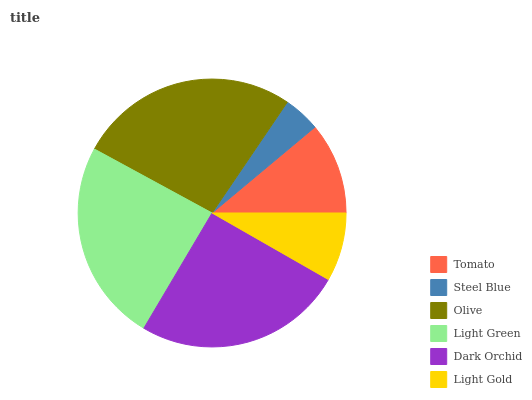Is Steel Blue the minimum?
Answer yes or no. Yes. Is Olive the maximum?
Answer yes or no. Yes. Is Olive the minimum?
Answer yes or no. No. Is Steel Blue the maximum?
Answer yes or no. No. Is Olive greater than Steel Blue?
Answer yes or no. Yes. Is Steel Blue less than Olive?
Answer yes or no. Yes. Is Steel Blue greater than Olive?
Answer yes or no. No. Is Olive less than Steel Blue?
Answer yes or no. No. Is Light Green the high median?
Answer yes or no. Yes. Is Tomato the low median?
Answer yes or no. Yes. Is Steel Blue the high median?
Answer yes or no. No. Is Light Gold the low median?
Answer yes or no. No. 